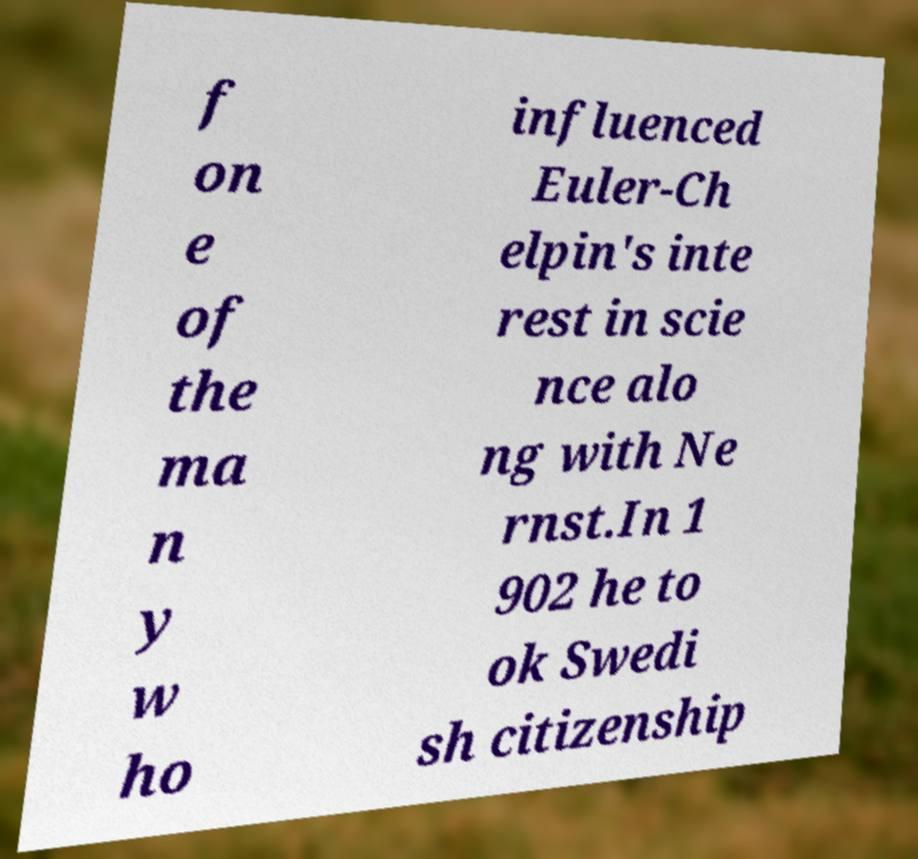I need the written content from this picture converted into text. Can you do that? f on e of the ma n y w ho influenced Euler-Ch elpin's inte rest in scie nce alo ng with Ne rnst.In 1 902 he to ok Swedi sh citizenship 